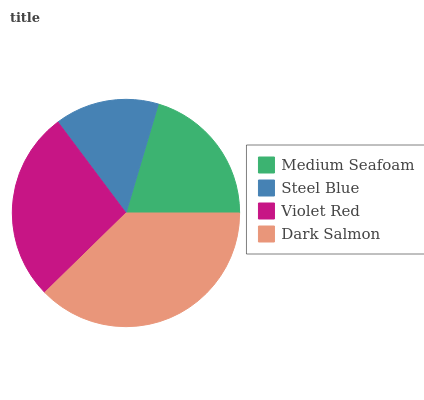Is Steel Blue the minimum?
Answer yes or no. Yes. Is Dark Salmon the maximum?
Answer yes or no. Yes. Is Violet Red the minimum?
Answer yes or no. No. Is Violet Red the maximum?
Answer yes or no. No. Is Violet Red greater than Steel Blue?
Answer yes or no. Yes. Is Steel Blue less than Violet Red?
Answer yes or no. Yes. Is Steel Blue greater than Violet Red?
Answer yes or no. No. Is Violet Red less than Steel Blue?
Answer yes or no. No. Is Violet Red the high median?
Answer yes or no. Yes. Is Medium Seafoam the low median?
Answer yes or no. Yes. Is Medium Seafoam the high median?
Answer yes or no. No. Is Violet Red the low median?
Answer yes or no. No. 